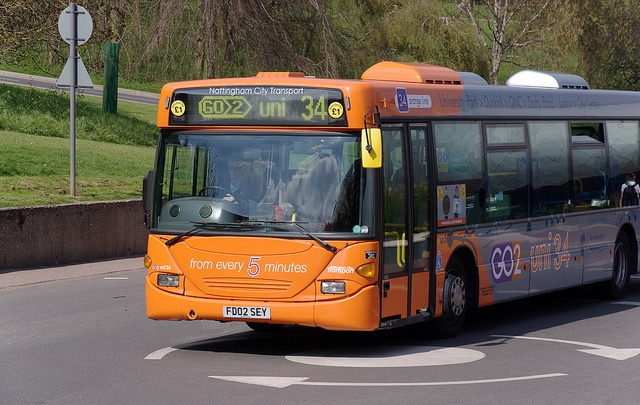Describe the objects in this image and their specific colors. I can see bus in olive, black, gray, and orange tones, people in olive and gray tones, people in olive, gray, blue, and darkgray tones, and backpack in olive, black, navy, gray, and darkblue tones in this image. 